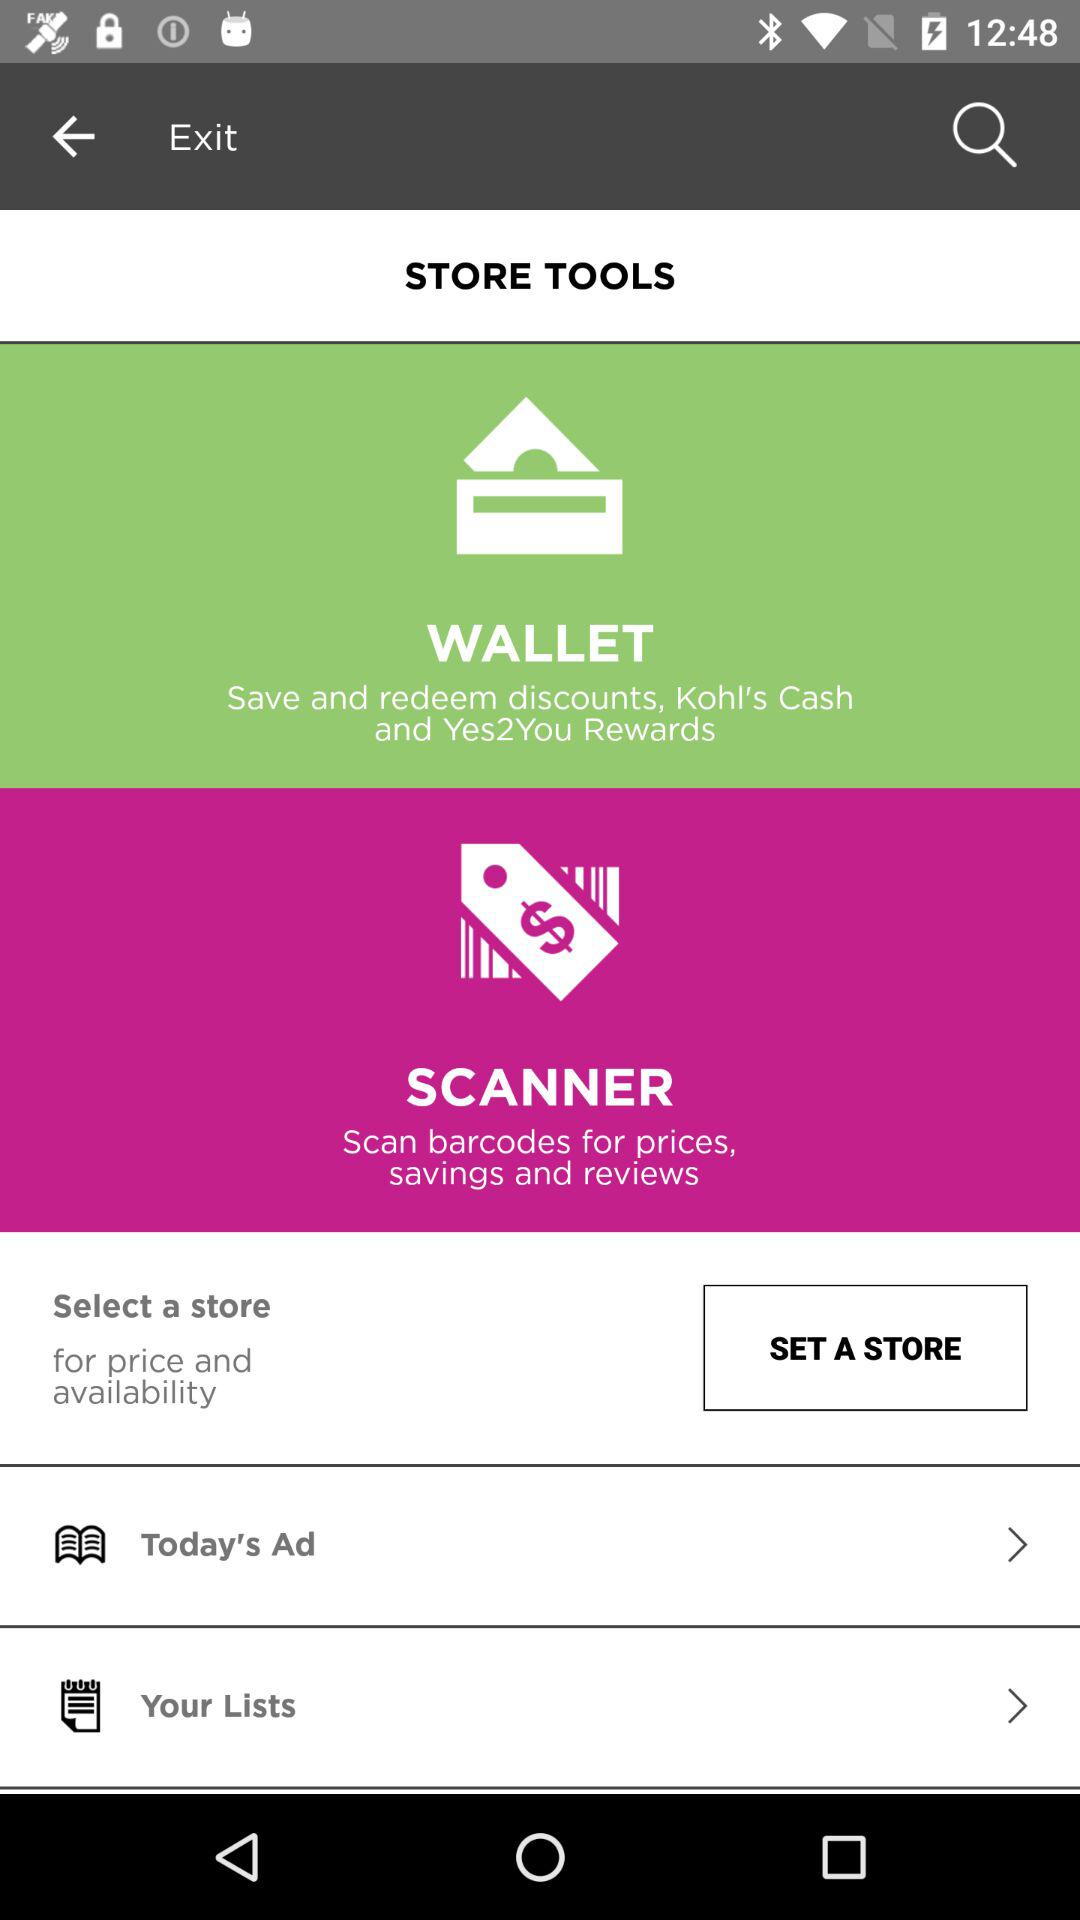Which tool is used to scan barcodes for prices, savings and reviews? The tool that is used to scan barcodes for prices, savings and reviews is "SCANNER". 